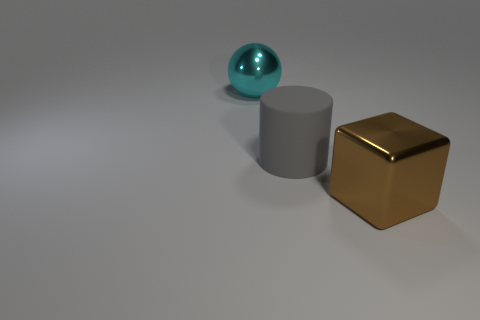Subtract all cylinders. How many objects are left? 2 Subtract all small red shiny cylinders. Subtract all big brown metal blocks. How many objects are left? 2 Add 3 large metallic objects. How many large metallic objects are left? 5 Add 1 tiny red metallic objects. How many tiny red metallic objects exist? 1 Add 3 big blocks. How many objects exist? 6 Subtract 0 green cubes. How many objects are left? 3 Subtract all yellow cubes. Subtract all brown cylinders. How many cubes are left? 1 Subtract all yellow cubes. How many purple balls are left? 0 